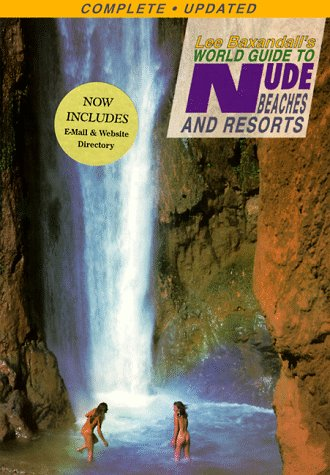Is this book related to Christian Books & Bibles? No, this book does not relate to Christian Books & Bibles; instead, it caters to a niche travel audience interested in naturism. 